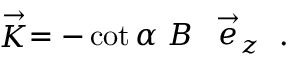Convert formula to latex. <formula><loc_0><loc_0><loc_500><loc_500>\stackrel { \rightarrow } { K } = - \cot \alpha \, B \, \stackrel { \rightarrow } { e } _ { z } .</formula> 